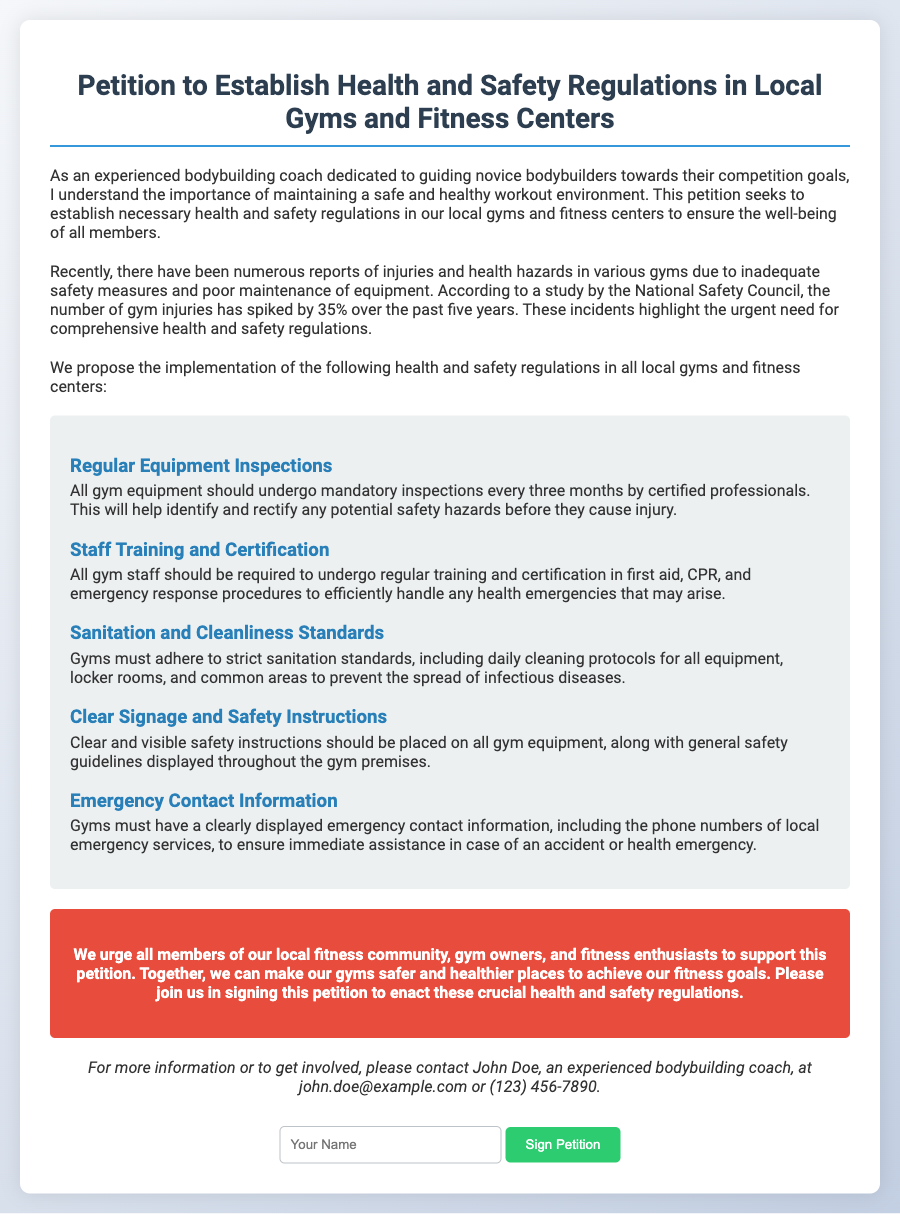What is the main purpose of this petition? The petition aims to establish necessary health and safety regulations in local gyms and fitness centers for the well-being of all members.
Answer: Establish health and safety regulations How often should gym equipment undergo inspections? The petition states that all gym equipment should undergo mandatory inspections every three months.
Answer: Every three months What training should gym staff undergo? Gym staff should be required to undergo regular training and certification in first aid, CPR, and emergency response procedures.
Answer: First aid, CPR, emergency response What is the percentage increase in gym injuries over the past five years? The document mentions that the number of gym injuries has spiked by 35% over the past five years.
Answer: 35% Who is the contact person for more information about the petition? The document specifies John Doe as the contact person for more information about the petition.
Answer: John Doe What should be displayed on all gym equipment according to the petition? The petition states that clear and visible safety instructions should be placed on all gym equipment.
Answer: Safety instructions What color is the call-to-action section? The call-to-action section is described as having a background color of #e74c3c.
Answer: #e74c3c What should gyms adhere to regarding sanitation? Gyms must adhere to strict sanitation standards, including daily cleaning protocols for all equipment, locker rooms, and common areas.
Answer: Strict sanitation standards 